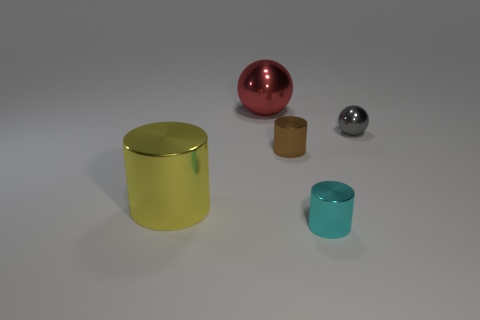Subtract all small cylinders. How many cylinders are left? 1 Add 3 brown things. How many objects exist? 8 Subtract all spheres. How many objects are left? 3 Add 3 shiny cylinders. How many shiny cylinders are left? 6 Add 4 red metallic balls. How many red metallic balls exist? 5 Subtract 0 red cylinders. How many objects are left? 5 Subtract all small gray metallic things. Subtract all red objects. How many objects are left? 3 